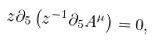Convert formula to latex. <formula><loc_0><loc_0><loc_500><loc_500>z \partial _ { 5 } \left ( z ^ { - 1 } \partial _ { 5 } A ^ { \mu } \right ) = 0 ,</formula> 